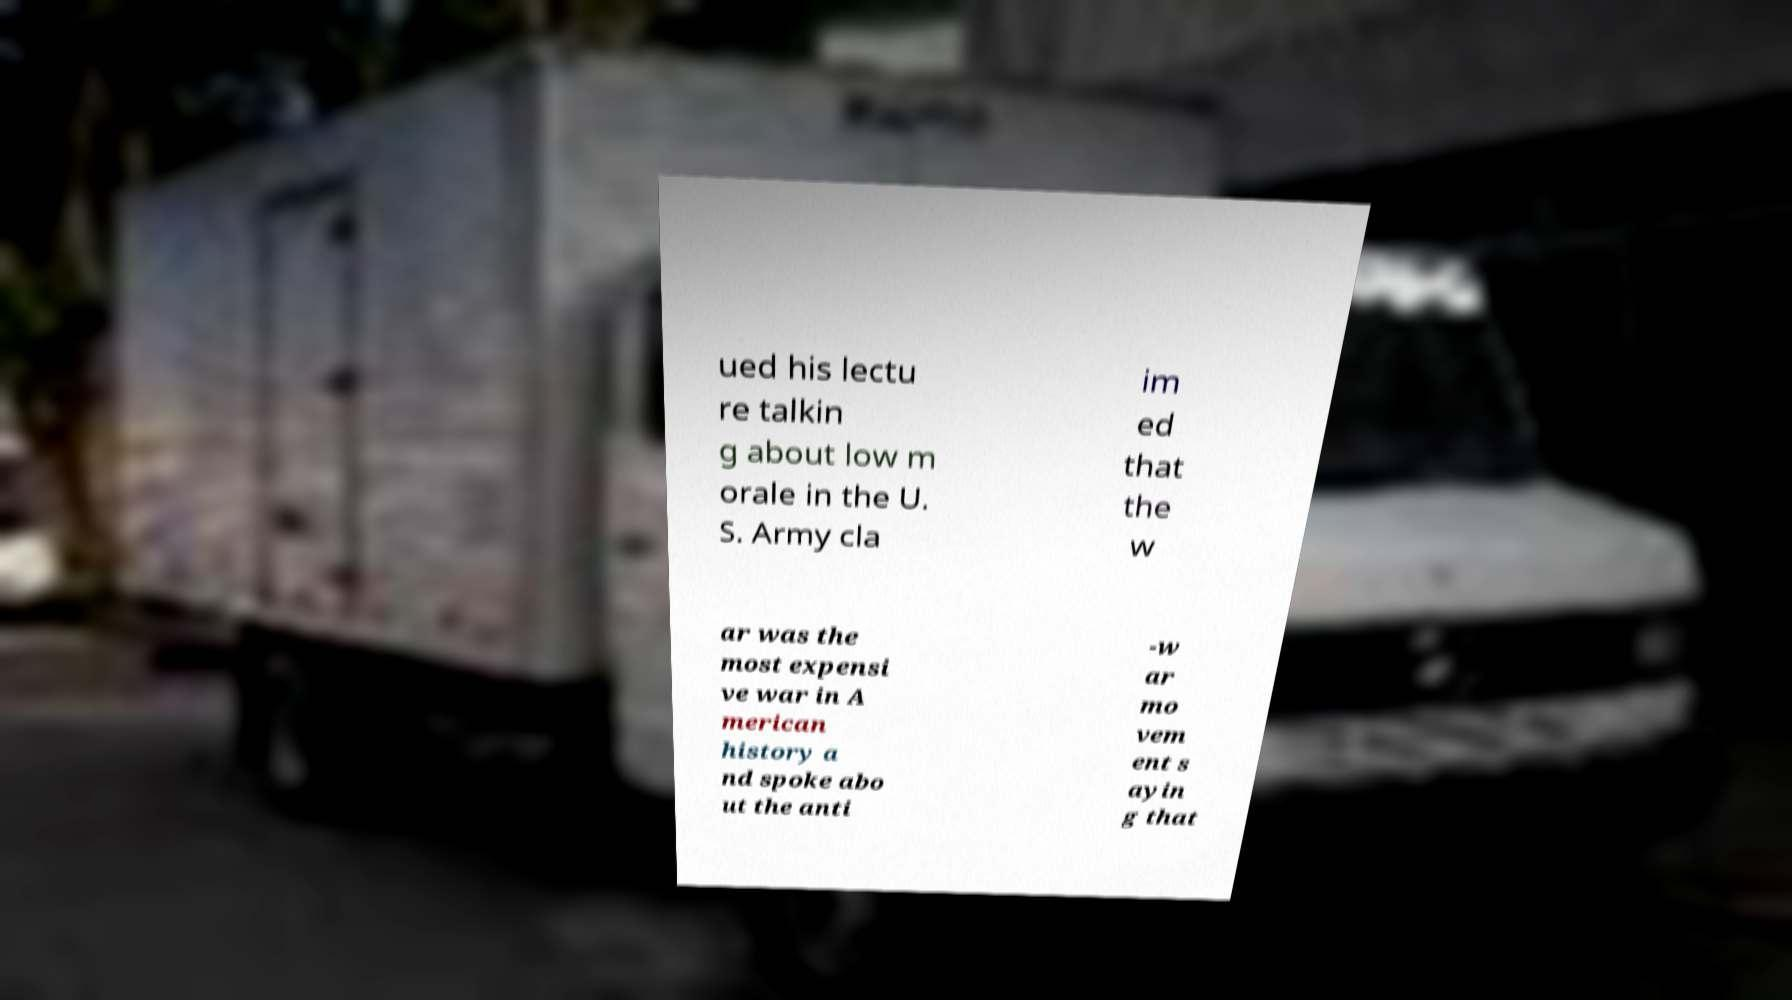Can you accurately transcribe the text from the provided image for me? ued his lectu re talkin g about low m orale in the U. S. Army cla im ed that the w ar was the most expensi ve war in A merican history a nd spoke abo ut the anti -w ar mo vem ent s ayin g that 